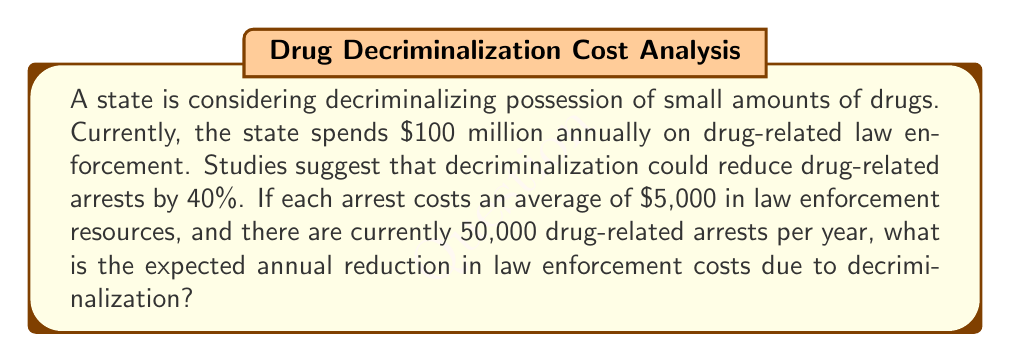Show me your answer to this math problem. Let's approach this step-by-step:

1. Calculate the current cost of drug-related arrests:
   $$ \text{Current cost} = 50,000 \text{ arrests} \times \$5,000 \text{ per arrest} = \$250 \text{ million} $$

2. Calculate the expected reduction in arrests:
   $$ \text{Reduction} = 50,000 \text{ arrests} \times 40\% = 20,000 \text{ arrests} $$

3. Calculate the cost savings from reduced arrests:
   $$ \text{Savings} = 20,000 \text{ arrests} \times \$5,000 \text{ per arrest} = \$100 \text{ million} $$

4. The total current law enforcement costs are $100 million, which includes costs beyond just arrests. We need to add the arrest-related savings to this base amount:
   $$ \text{Total expected reduction} = \$100 \text{ million} $$

Therefore, the expected annual reduction in law enforcement costs due to decriminalization is $100 million.
Answer: $100 million 